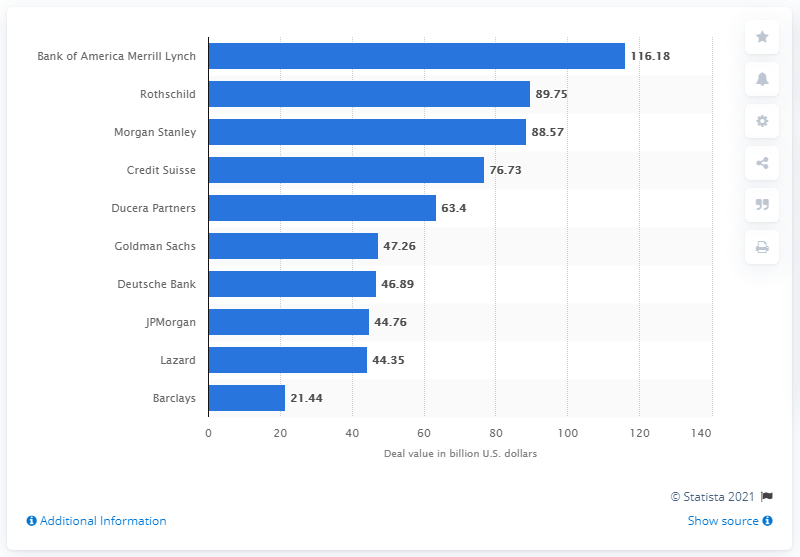Highlight a few significant elements in this photo. Bank of America Merrill Lynch was the leading advisor for M&A deals in Germany in 2016. The total deal value of Bank of America Merrill Lynch in 2016 was 116.18. 